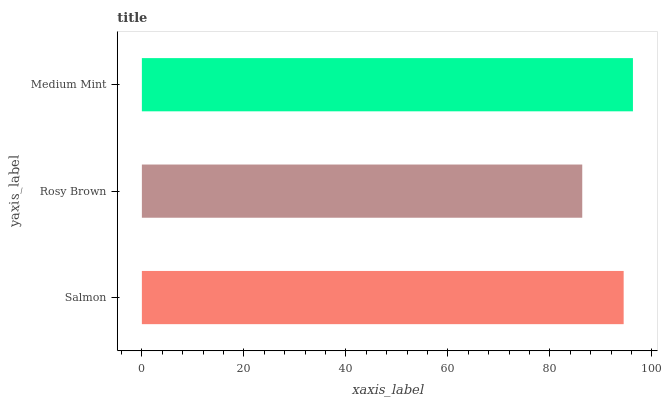Is Rosy Brown the minimum?
Answer yes or no. Yes. Is Medium Mint the maximum?
Answer yes or no. Yes. Is Medium Mint the minimum?
Answer yes or no. No. Is Rosy Brown the maximum?
Answer yes or no. No. Is Medium Mint greater than Rosy Brown?
Answer yes or no. Yes. Is Rosy Brown less than Medium Mint?
Answer yes or no. Yes. Is Rosy Brown greater than Medium Mint?
Answer yes or no. No. Is Medium Mint less than Rosy Brown?
Answer yes or no. No. Is Salmon the high median?
Answer yes or no. Yes. Is Salmon the low median?
Answer yes or no. Yes. Is Medium Mint the high median?
Answer yes or no. No. Is Rosy Brown the low median?
Answer yes or no. No. 